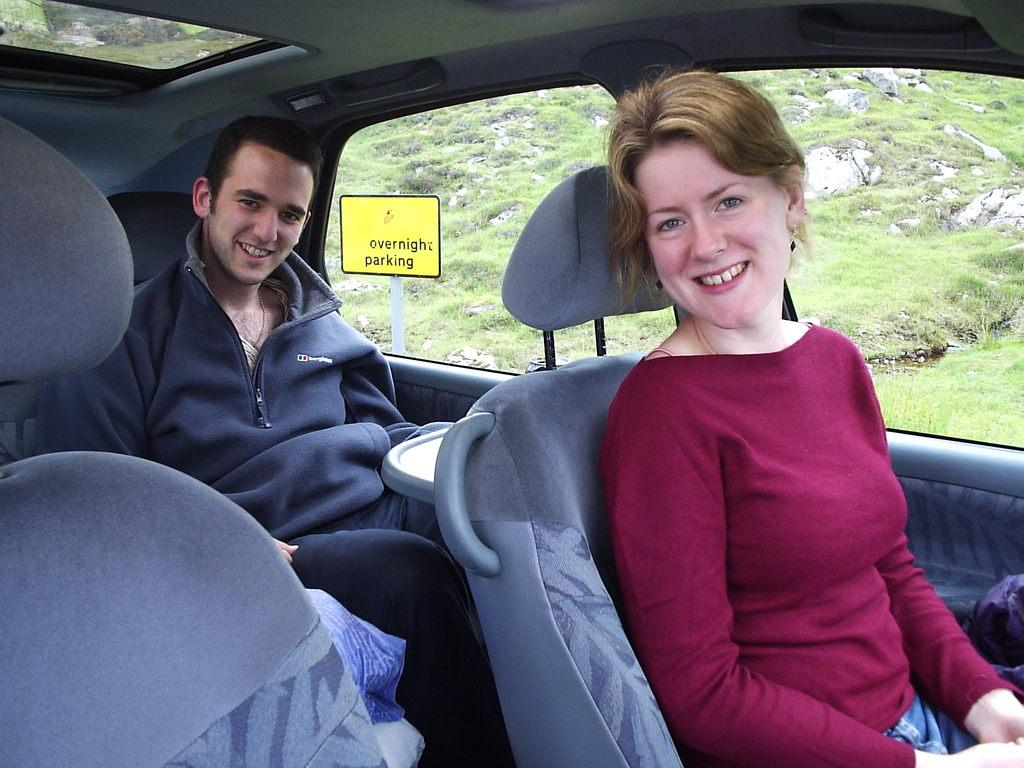What are the persons in the image doing? The persons in the image are sitting inside the car. What can be seen outside the car in the image? There is grass visible in the image. What type of activity are the fairies participating in on the grass in the image? There are no fairies present in the image; it only shows persons sitting inside a car with grass visible in the background. 